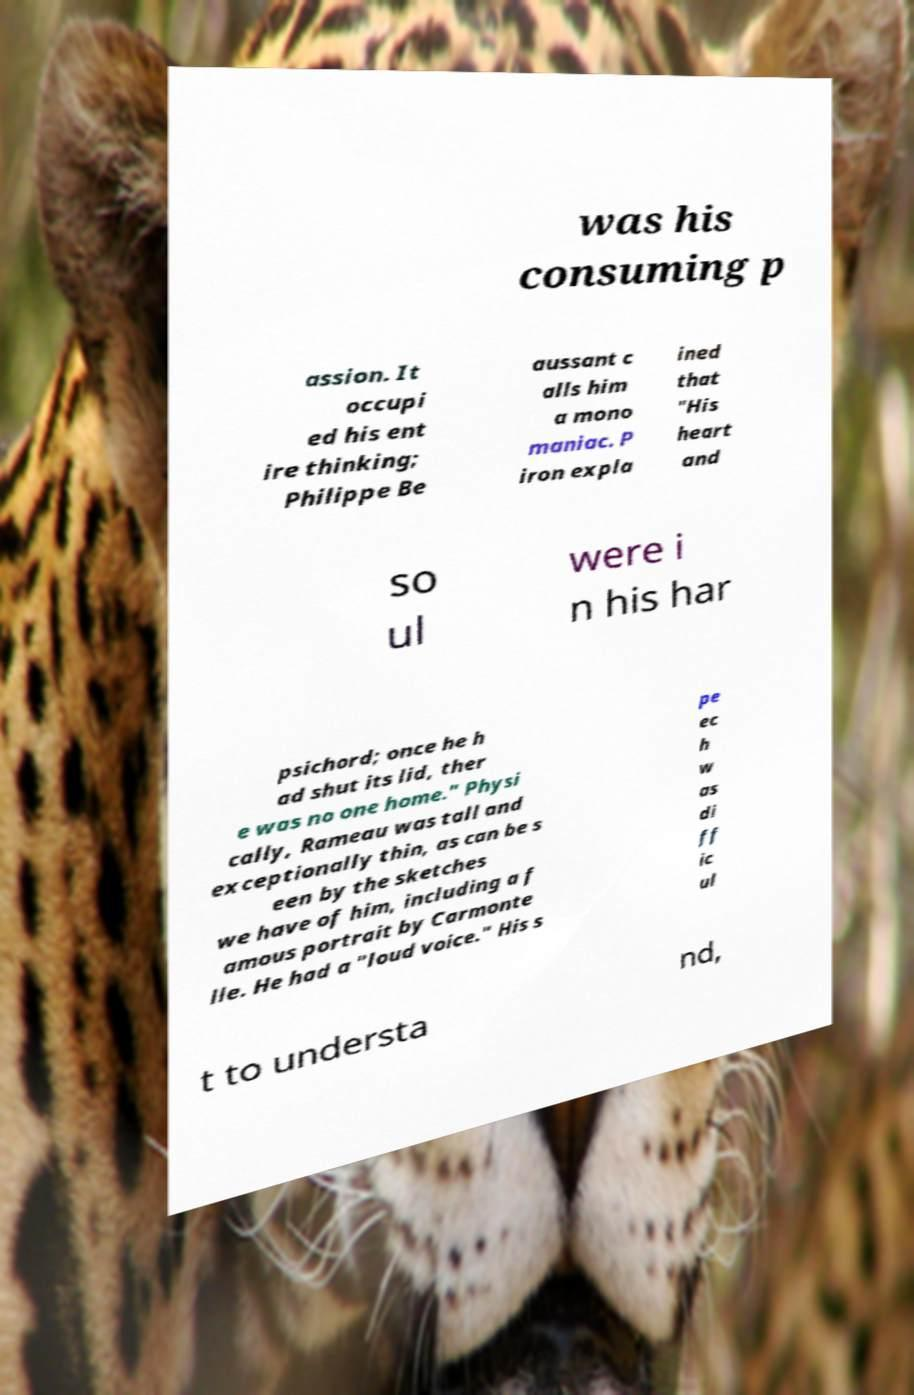Please read and relay the text visible in this image. What does it say? was his consuming p assion. It occupi ed his ent ire thinking; Philippe Be aussant c alls him a mono maniac. P iron expla ined that "His heart and so ul were i n his har psichord; once he h ad shut its lid, ther e was no one home." Physi cally, Rameau was tall and exceptionally thin, as can be s een by the sketches we have of him, including a f amous portrait by Carmonte lle. He had a "loud voice." His s pe ec h w as di ff ic ul t to understa nd, 